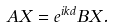<formula> <loc_0><loc_0><loc_500><loc_500>A X = e ^ { i k d } B X .</formula> 